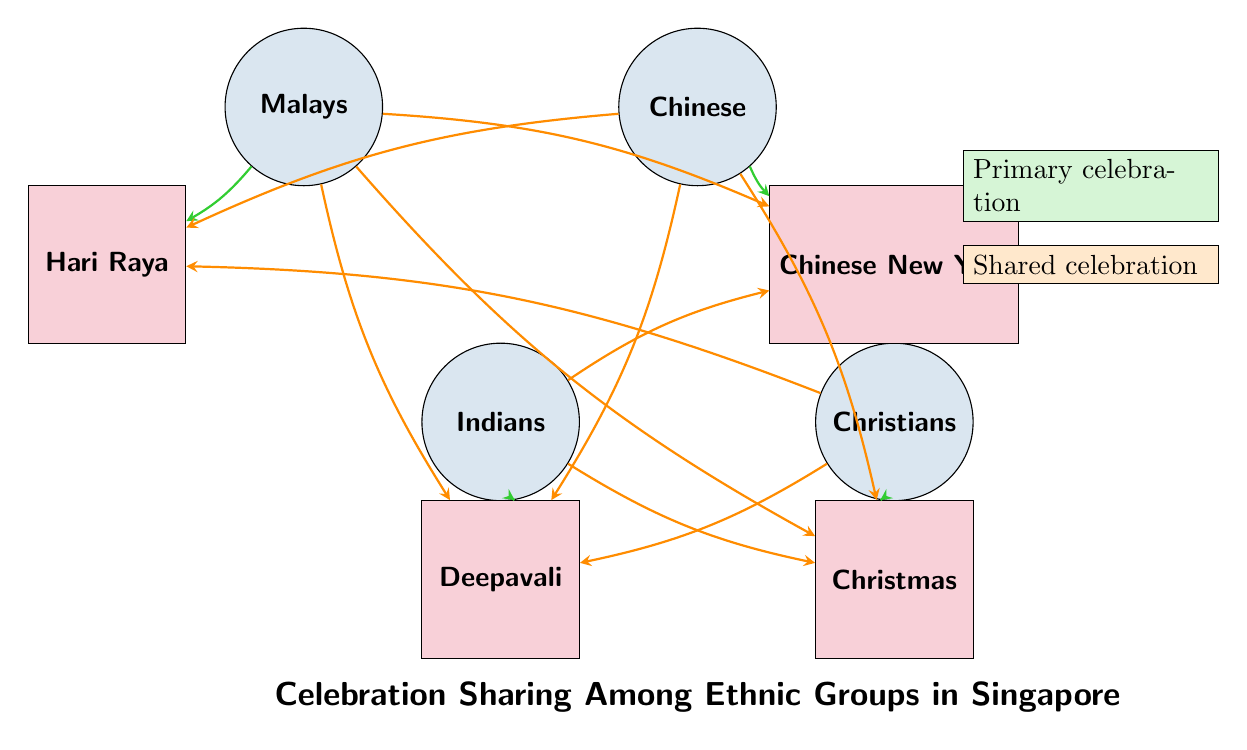What ethnic group is primarily associated with Hari Raya? According to the diagram, the link from "Malays" directly to "Hari Raya" indicates the primary association of the Malay ethnic group with this celebration.
Answer: Malays Which festival is directly linked to Indians? The link from "Indians" to "Deepavali" indicates that this festival is primarily celebrated by Indians.
Answer: Deepavali How many primary celebrations are there in the diagram? The primary celebrations are Hari Raya, Chinese New Year, Deepavali, and Christmas. Counting these yields a total of four primary celebrations.
Answer: 4 Which two ethnic groups share a connection to Christmas? The diagram shows links from both "Indians" and "Chinese" to "Christmas," indicating that both of these ethnic groups share a connection to this festival.
Answer: Indians, Chinese What festival is shared between the Chinese and Malays according to the diagram? The diagram includes a link from "Chinese" to "Hari Raya," and a link from "Malays" to "Chinese New Year," suggesting a shared connection to see the influence in both celebrations. However, since the question asks for a specific festival shared directly, we find that both groups directly connect to "Chinese New Year."
Answer: Chinese New Year Which ethnic group is least connected in terms of shared celebrations? By analyzing the connections, "Christians" have 3 shared connections (to Hari Raya, Deepavali, and Christmas) compared to others, thereby suggesting a lower degree of connection in terms of celebration sharing.
Answer: Christians How many celebrations do Malays share with other ethnic groups? In the diagram, there are connections from "Malays" to "Chinese New Year," "Deepavali," and "Christmas," indicating that Malays share a total of three celebrations with other ethnic groups.
Answer: 3 What type of festive connection is represented by the arrows from minorities to Christmas? The arrows from "Indians" and "Chinese" to "Christmas" indicate a shared celebration since this arrows color in the diagram represents shared connections rather than primary ownership.
Answer: Shared celebration 